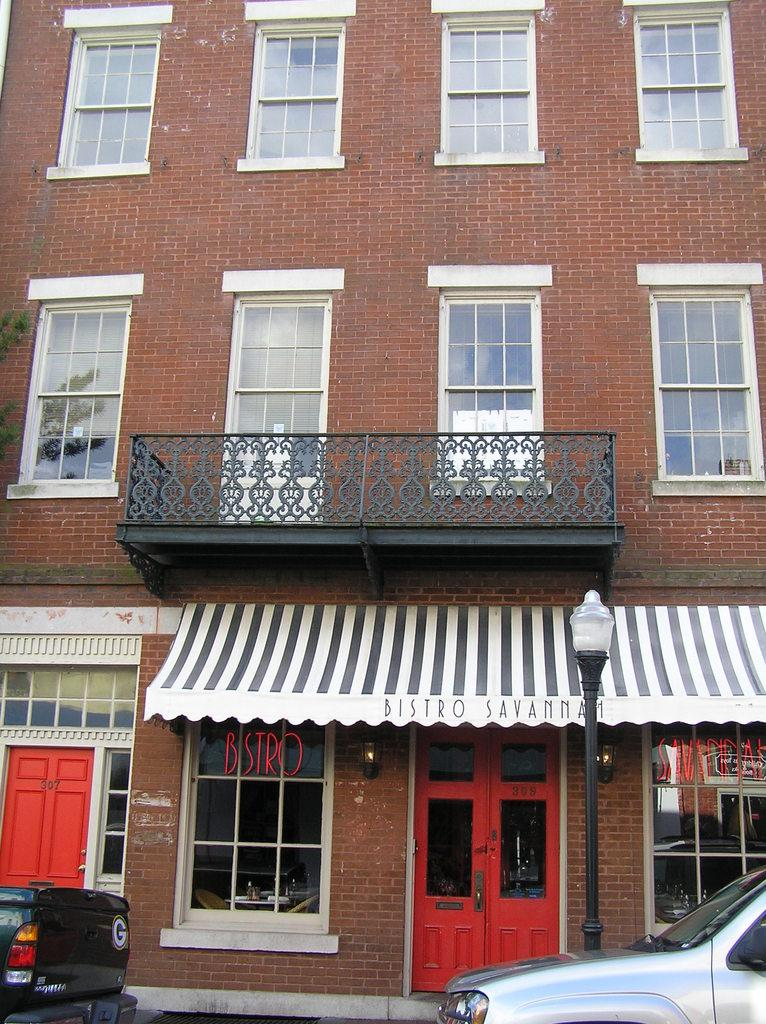What type of structure is visible in the image? There is a building in the image. Are there any vehicles present in the image? Yes, there are two vehicles parked in front of the building. How many yaks can be seen grazing near the building in the image? There are no yaks present in the image. What decision was made by the people inside the building before the image was taken? The image does not provide any information about decisions made by the people inside the building. 